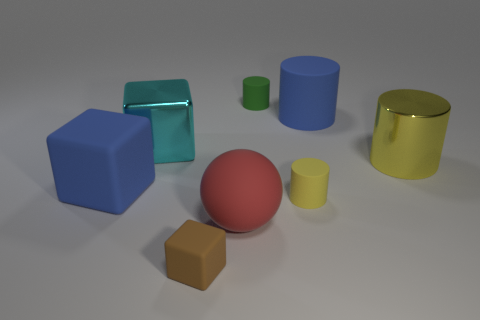Do the big blue thing that is on the right side of the large blue block and the small rubber thing that is right of the green cylinder have the same shape? yes 